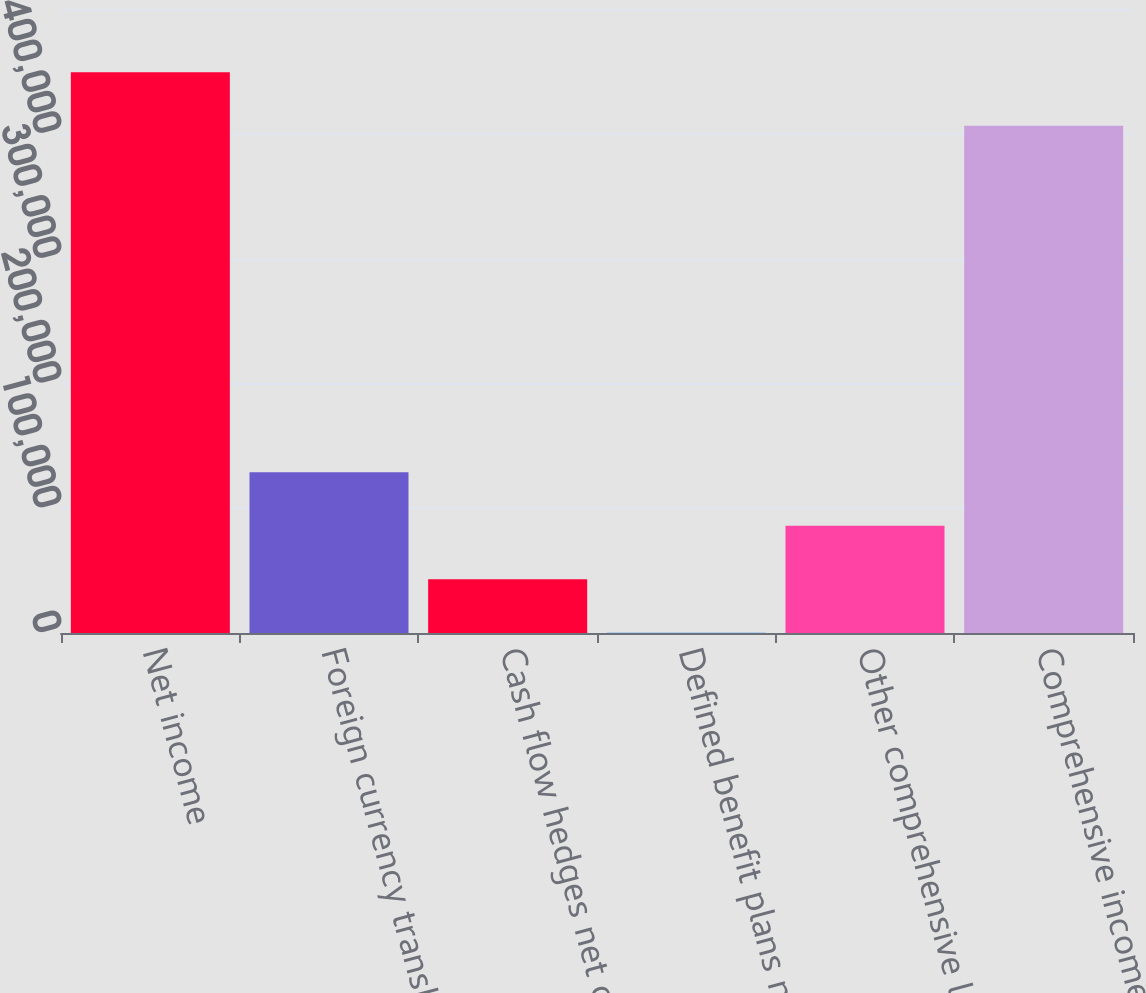<chart> <loc_0><loc_0><loc_500><loc_500><bar_chart><fcel>Net income<fcel>Foreign currency translation<fcel>Cash flow hedges net of tax<fcel>Defined benefit plans net of<fcel>Other comprehensive loss<fcel>Comprehensive income<nl><fcel>449378<fcel>128789<fcel>43055.6<fcel>189<fcel>85922.2<fcel>406511<nl></chart> 